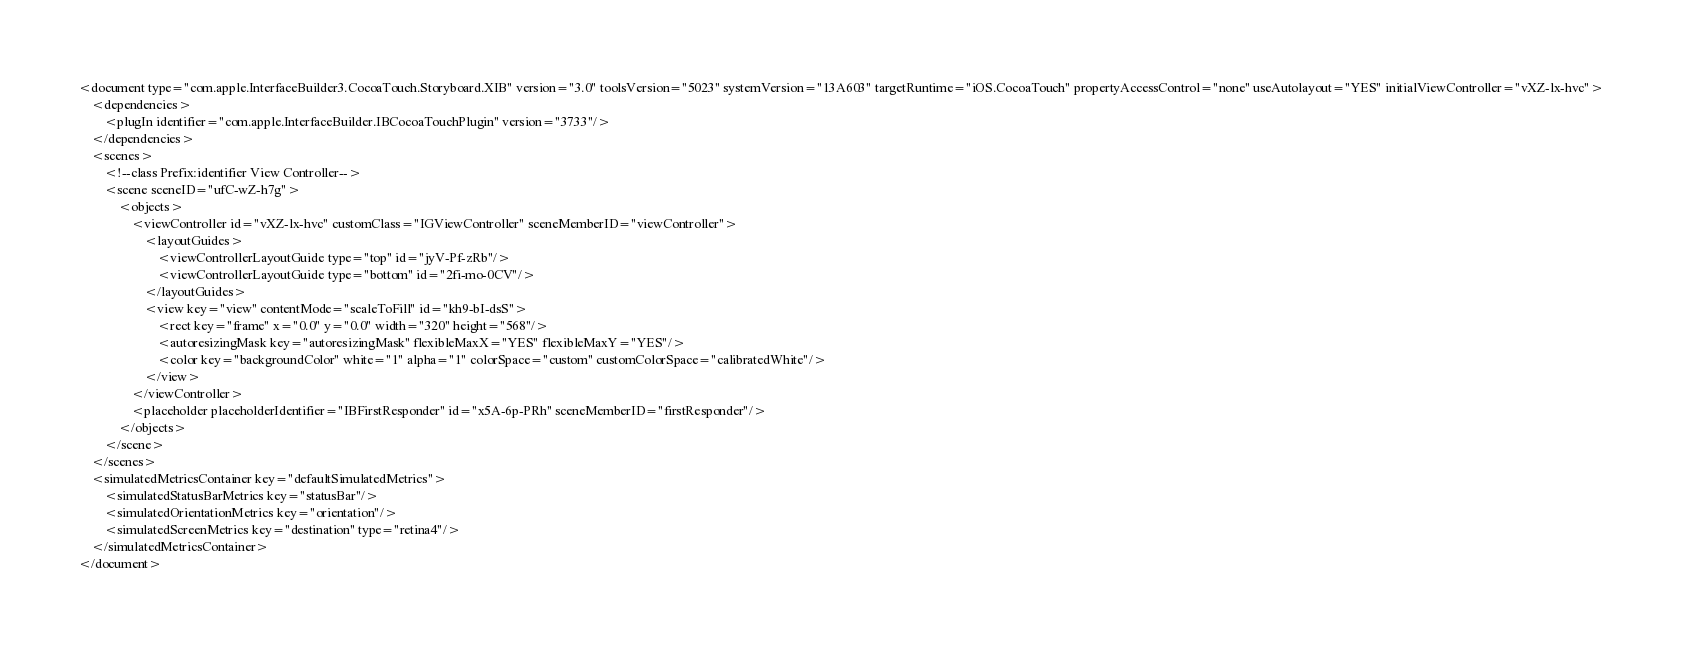<code> <loc_0><loc_0><loc_500><loc_500><_XML_><document type="com.apple.InterfaceBuilder3.CocoaTouch.Storyboard.XIB" version="3.0" toolsVersion="5023" systemVersion="13A603" targetRuntime="iOS.CocoaTouch" propertyAccessControl="none" useAutolayout="YES" initialViewController="vXZ-lx-hvc">
    <dependencies>
        <plugIn identifier="com.apple.InterfaceBuilder.IBCocoaTouchPlugin" version="3733"/>
    </dependencies>
    <scenes>
        <!--class Prefix:identifier View Controller-->
        <scene sceneID="ufC-wZ-h7g">
            <objects>
                <viewController id="vXZ-lx-hvc" customClass="IGViewController" sceneMemberID="viewController">
                    <layoutGuides>
                        <viewControllerLayoutGuide type="top" id="jyV-Pf-zRb"/>
                        <viewControllerLayoutGuide type="bottom" id="2fi-mo-0CV"/>
                    </layoutGuides>
                    <view key="view" contentMode="scaleToFill" id="kh9-bI-dsS">
                        <rect key="frame" x="0.0" y="0.0" width="320" height="568"/>
                        <autoresizingMask key="autoresizingMask" flexibleMaxX="YES" flexibleMaxY="YES"/>
                        <color key="backgroundColor" white="1" alpha="1" colorSpace="custom" customColorSpace="calibratedWhite"/>
                    </view>
                </viewController>
                <placeholder placeholderIdentifier="IBFirstResponder" id="x5A-6p-PRh" sceneMemberID="firstResponder"/>
            </objects>
        </scene>
    </scenes>
    <simulatedMetricsContainer key="defaultSimulatedMetrics">
        <simulatedStatusBarMetrics key="statusBar"/>
        <simulatedOrientationMetrics key="orientation"/>
        <simulatedScreenMetrics key="destination" type="retina4"/>
    </simulatedMetricsContainer>
</document>
</code> 